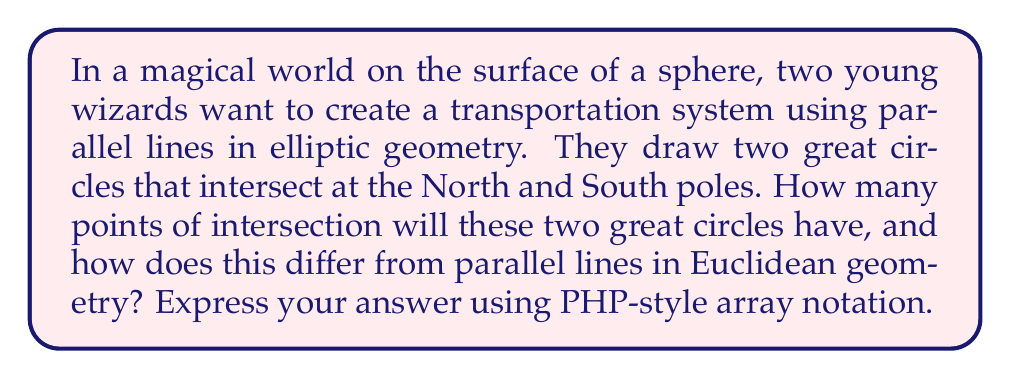Provide a solution to this math problem. Let's approach this step-by-step:

1. In Euclidean geometry, parallel lines never intersect. We can express this as:
   $$\text{Intersections}_{\text{Euclidean}} = 0$$

2. However, in elliptic geometry (which is the geometry on the surface of a sphere), the concept of parallel lines is different:
   - Great circles are the equivalent of straight lines on a sphere.
   - Any two great circles always intersect at exactly two antipodal points.

3. In our magical world:
   - The two great circles intersect at the North and South poles.
   - These poles are antipodal points on the sphere.

4. Therefore, the number of intersections in elliptic geometry is:
   $$\text{Intersections}_{\text{Elliptic}} = 2$$

5. To express this in PHP-style array notation, we can create an associative array:
   ```php
   $intersections = array(
       "Euclidean" => 0,
       "Elliptic" => 2
   );
   ```

This magical transportation system demonstrates a fundamental difference between Euclidean and elliptic geometries, showcasing how parallel lines behave differently in non-Euclidean spaces.
Answer: array("Euclidean" => 0, "Elliptic" => 2) 